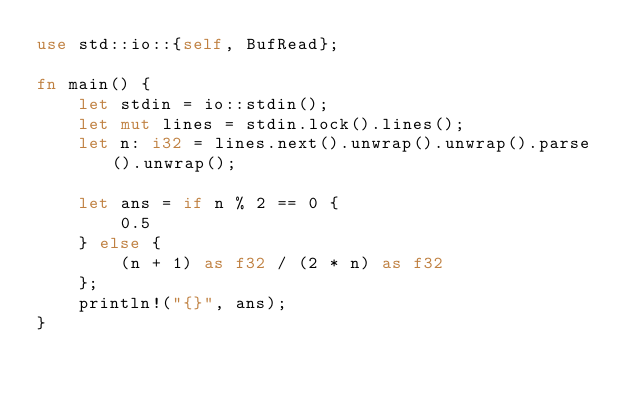Convert code to text. <code><loc_0><loc_0><loc_500><loc_500><_Rust_>use std::io::{self, BufRead};

fn main() {
    let stdin = io::stdin();
    let mut lines = stdin.lock().lines();
    let n: i32 = lines.next().unwrap().unwrap().parse().unwrap();

    let ans = if n % 2 == 0 {
        0.5
    } else {
        (n + 1) as f32 / (2 * n) as f32
    };
    println!("{}", ans);
}
</code> 